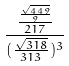Convert formula to latex. <formula><loc_0><loc_0><loc_500><loc_500>\frac { \frac { \frac { \sqrt { 4 4 9 } } { 9 } } { 2 1 7 } } { ( \frac { \sqrt { 3 1 8 } } { 3 1 3 } ) ^ { 3 } }</formula> 